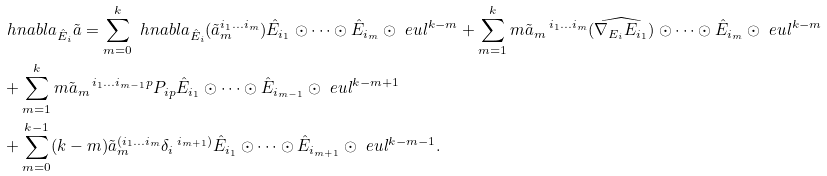<formula> <loc_0><loc_0><loc_500><loc_500>& \ h n a b l a _ { \hat { E } _ { i } } \tilde { a } = \sum _ { m = 0 } ^ { k } \ h n a b l a _ { \hat { E } _ { i } } ( \tilde { a } _ { m } ^ { i _ { 1 } \dots i _ { m } } ) \hat { E } _ { i _ { 1 } } \odot \dots \odot \hat { E } _ { i _ { m } } \odot \ e u l ^ { k - m } + \sum _ { m = 1 } ^ { k } m \tilde { a } _ { m } \, ^ { i _ { 1 } \dots i _ { m } } ( \widehat { \nabla _ { E _ { i } } E _ { i _ { 1 } } } ) \odot \dots \odot \hat { E } _ { i _ { m } } \odot \ e u l ^ { k - m } \\ & + \sum _ { m = 1 } ^ { k } m \tilde { a } _ { m } \, ^ { i _ { 1 } \dots i _ { m - 1 } p } P _ { i p } \hat { E } _ { i _ { 1 } } \odot \dots \odot \hat { E } _ { i _ { m - 1 } } \odot \ e u l ^ { k - m + 1 } \\ & + \sum _ { m = 0 } ^ { k - 1 } ( k - m ) \tilde { a } _ { m } ^ { ( i _ { 1 } \dots i _ { m } } \delta _ { i } \, ^ { i _ { m + 1 } ) } \hat { E } _ { i _ { 1 } } \odot \dots \odot \hat { E } _ { i _ { m + 1 } } \odot \ e u l ^ { k - m - 1 } .</formula> 